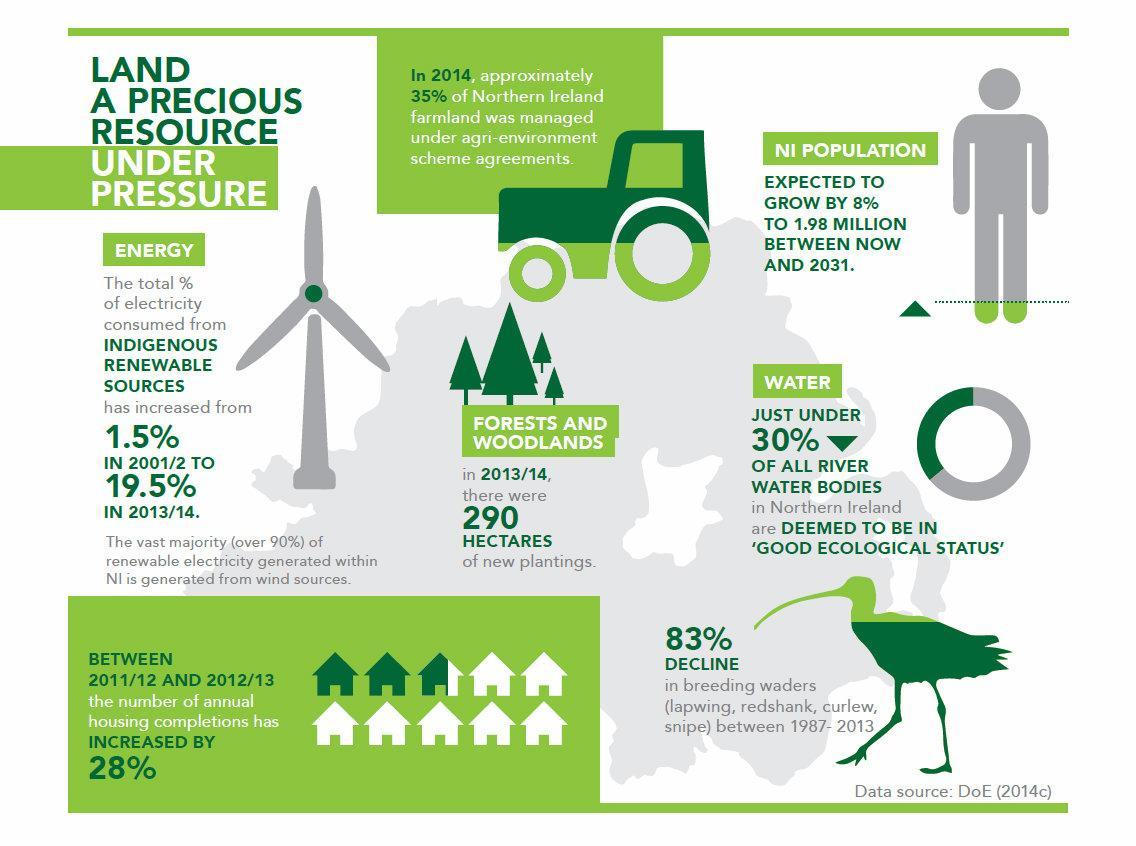What is the expected growth in population in Northern Ireland by 2031?
Answer the question with a short phrase. 1.98 million From which source is most of renewable electricity generated in North Ireland? wind What is the increase in total % of electricity consumed from indigenous renewable sources from 2001/2 to 2013/14? 18% How much expansion did woodlands and forests see in 2013/14? 290 hectares 